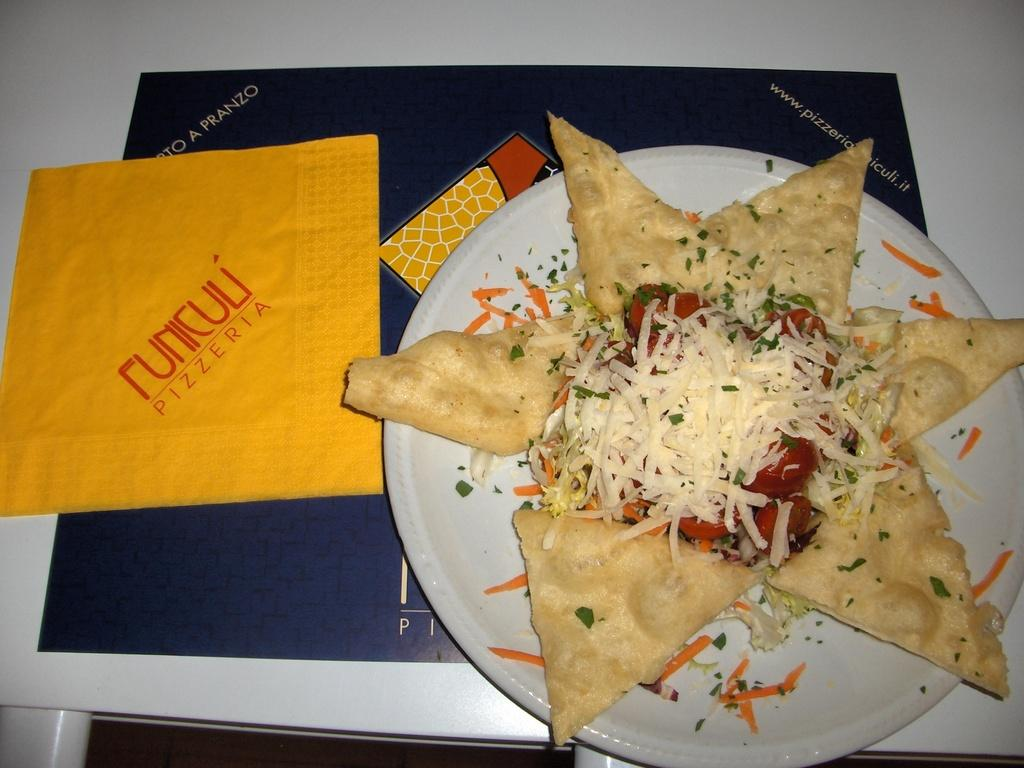<image>
Write a terse but informative summary of the picture. A plate with an appetizer is laid out next to a tissue from a pizzeria. 